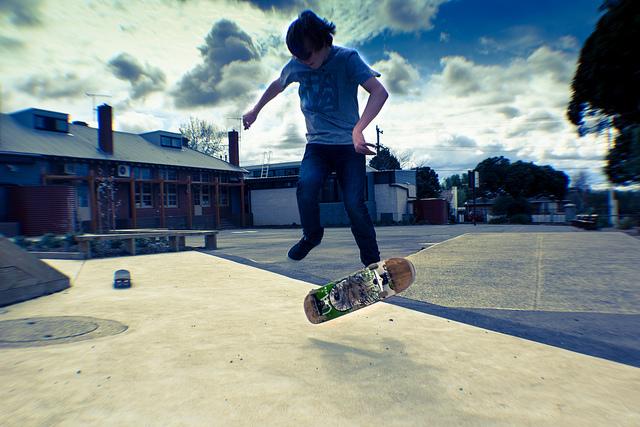Is he jumping over the pool?
Quick response, please. No. Where is the man skateboarding?
Short answer required. Parking lot. Does this boy know how to skateboard?
Quick response, please. Yes. Are there clouds in the sky?
Keep it brief. Yes. 